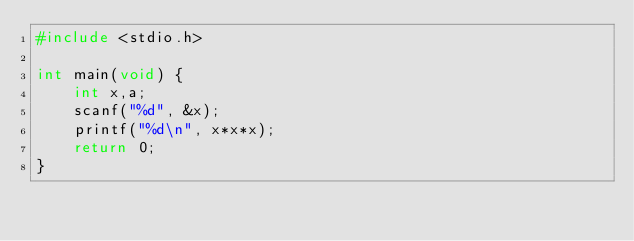<code> <loc_0><loc_0><loc_500><loc_500><_C_>#include <stdio.h>

int main(void) {
	int x,a;
	scanf("%d", &x);
	printf("%d\n", x*x*x);
	return 0;
}
</code> 